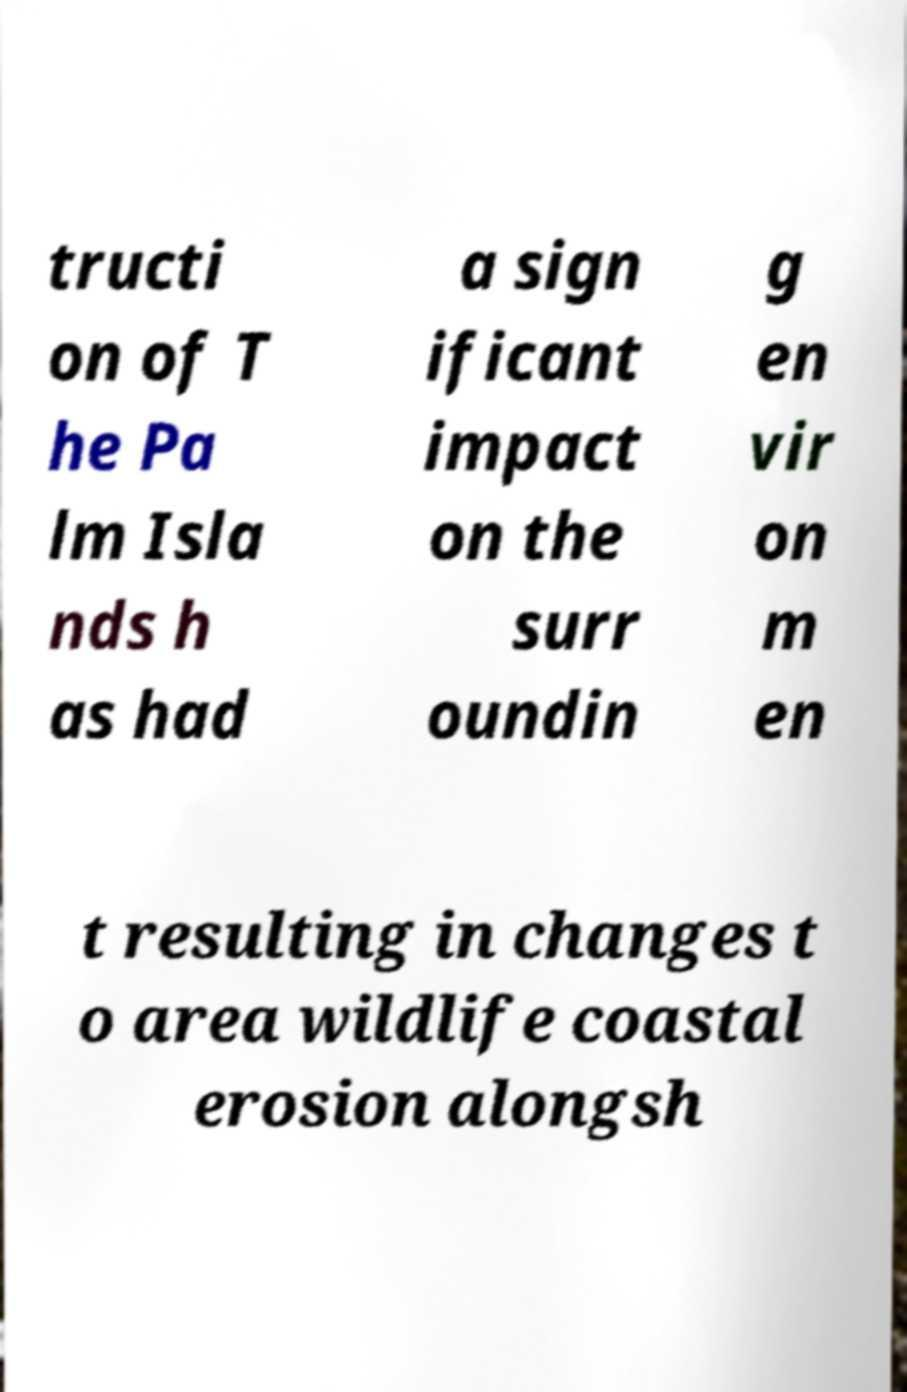Can you read and provide the text displayed in the image?This photo seems to have some interesting text. Can you extract and type it out for me? tructi on of T he Pa lm Isla nds h as had a sign ificant impact on the surr oundin g en vir on m en t resulting in changes t o area wildlife coastal erosion alongsh 